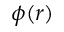Convert formula to latex. <formula><loc_0><loc_0><loc_500><loc_500>\phi ( r )</formula> 